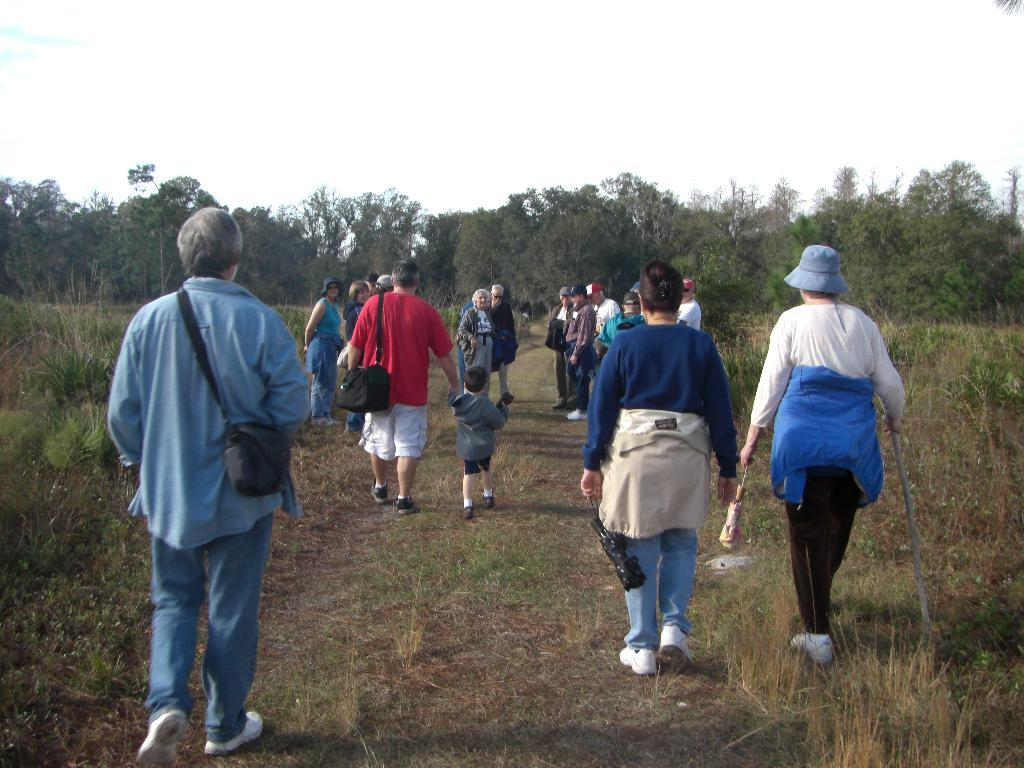What are the people in the image doing? There are people standing in the image, some of whom are carrying bags and holding objects. What type of vegetation can be seen in the image? There is dried grass visible in the image, as well as trees. What is visible at the top of the image? The sky is visible at the top of the image. What direction is the jelly moving in the image? There is no jelly present in the image, so it cannot be moving in any direction. 